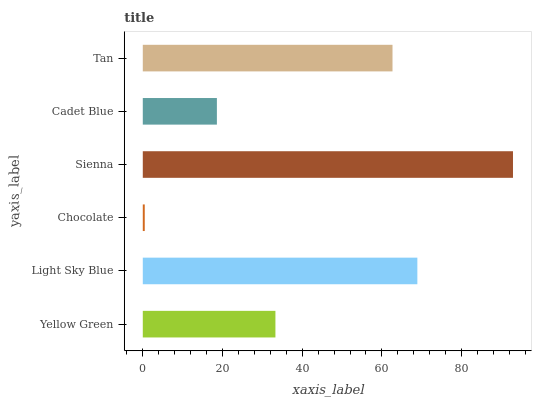Is Chocolate the minimum?
Answer yes or no. Yes. Is Sienna the maximum?
Answer yes or no. Yes. Is Light Sky Blue the minimum?
Answer yes or no. No. Is Light Sky Blue the maximum?
Answer yes or no. No. Is Light Sky Blue greater than Yellow Green?
Answer yes or no. Yes. Is Yellow Green less than Light Sky Blue?
Answer yes or no. Yes. Is Yellow Green greater than Light Sky Blue?
Answer yes or no. No. Is Light Sky Blue less than Yellow Green?
Answer yes or no. No. Is Tan the high median?
Answer yes or no. Yes. Is Yellow Green the low median?
Answer yes or no. Yes. Is Yellow Green the high median?
Answer yes or no. No. Is Tan the low median?
Answer yes or no. No. 